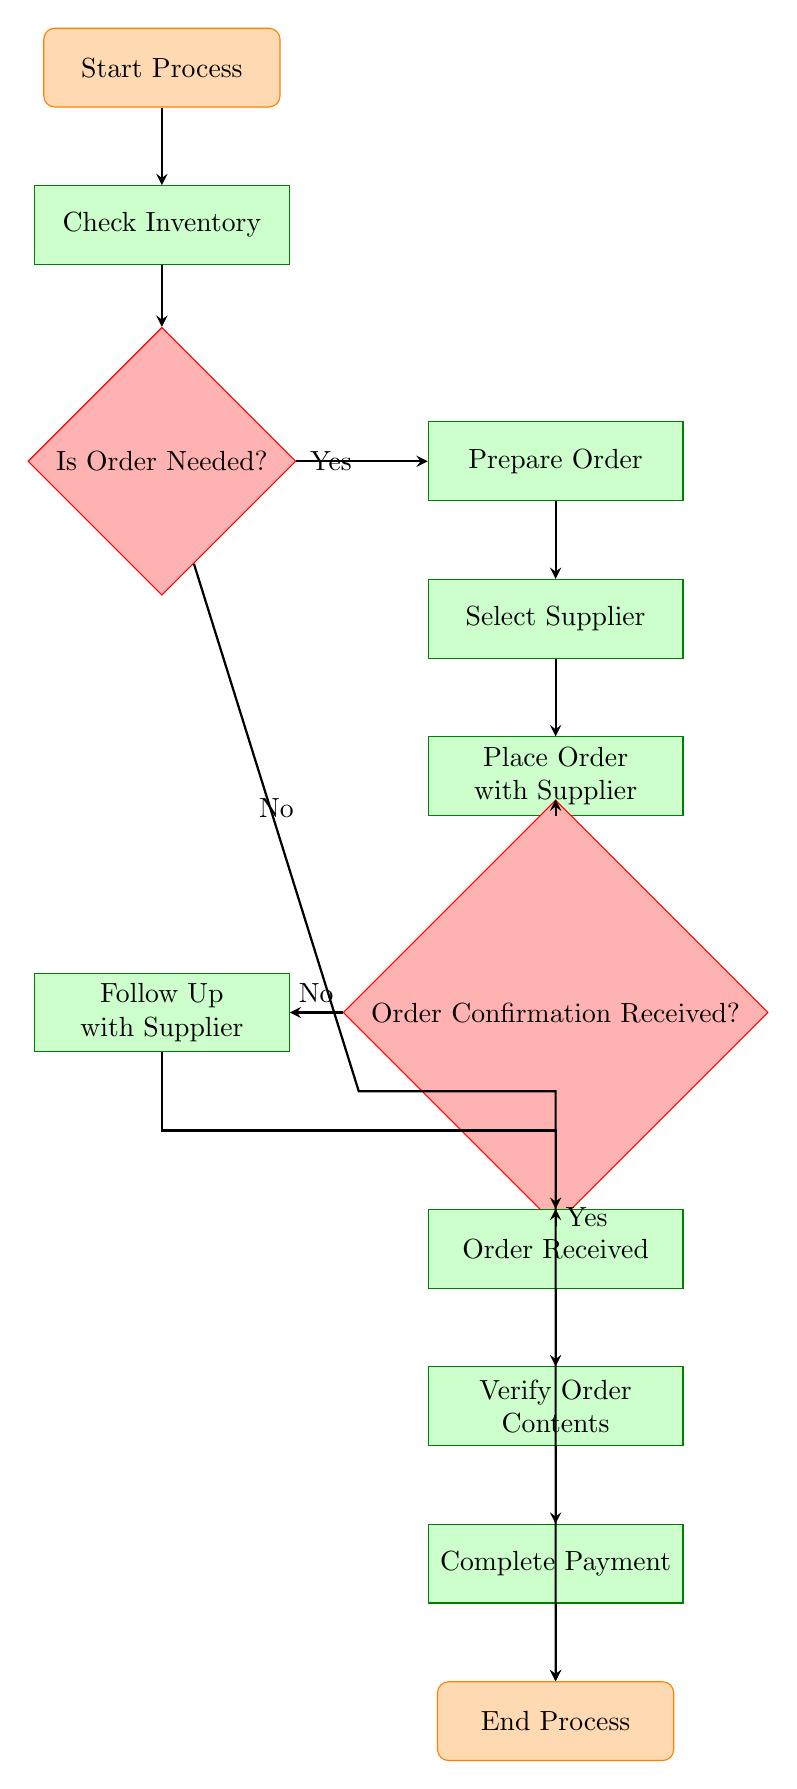What is the first step in the supplier order process? The flowchart indicates that the first node is labeled "Start Process," which represents the initiation of the entire process.
Answer: Start Process How many decision nodes are present in the diagram? The flowchart includes two decision nodes: "Is Order Needed?" and "Order Confirmation Received?" Therefore, the total count is two.
Answer: 2 What task follows after "Prepare Order"? According to the flowchart, after "Prepare Order," the next task is "Select Supplier," which is clearly indicated in the sequence of tasks.
Answer: Select Supplier What happens if the order is not needed? If the order is not needed, the flowchart shows that it leads directly to the end of the process, terminating the flow without any further actions.
Answer: End Process What is the last task before completing payment? The final task before completing the payment is "Verify Order Contents," which is placed directly before the "Complete Payment" task in the diagram flow.
Answer: Verify Order Contents What decision is made after placing an order with the supplier? After placing an order, the decision made is whether "Order Confirmation Received?" This is a critical checkpoint in the process for determining the next steps.
Answer: Order Confirmation Received? If "Yes" is the answer to the order confirmation question, which task follows? If the answer is "Yes" to the order confirmation question, the next task indicated in the flowchart is "Order Received," signaling a successful order progression.
Answer: Order Received What task occurs if order confirmation is not received? If the order confirmation is not received, the flowchart directs the process to "Follow Up with Supplier," indicating the need to check with the supplier about the order status.
Answer: Follow Up with Supplier 